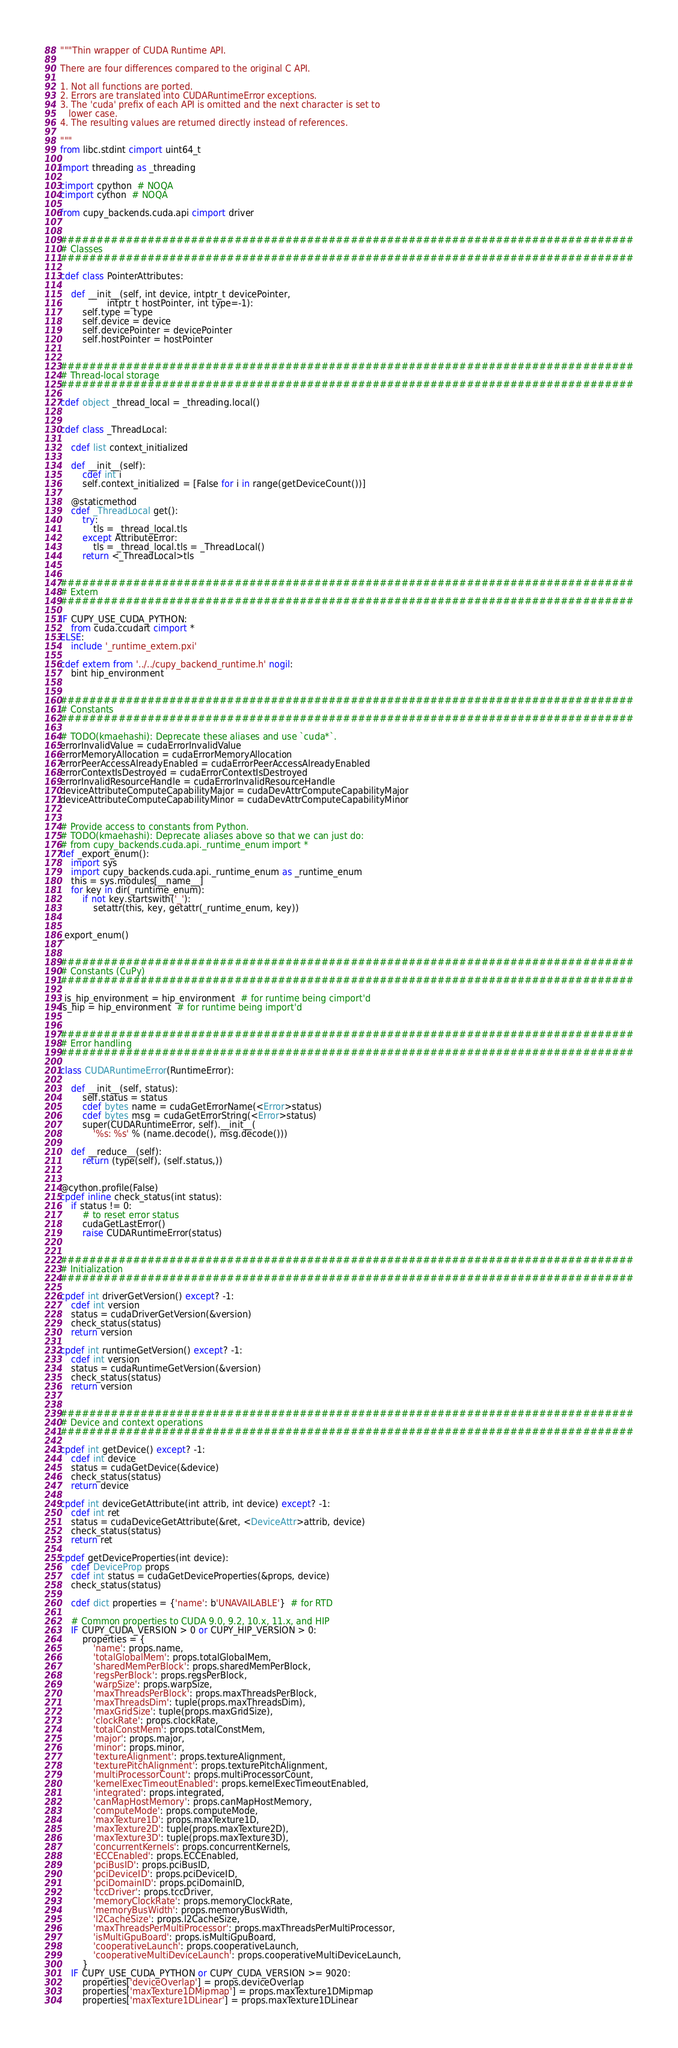Convert code to text. <code><loc_0><loc_0><loc_500><loc_500><_Cython_>"""Thin wrapper of CUDA Runtime API.

There are four differences compared to the original C API.

1. Not all functions are ported.
2. Errors are translated into CUDARuntimeError exceptions.
3. The 'cuda' prefix of each API is omitted and the next character is set to
   lower case.
4. The resulting values are returned directly instead of references.

"""
from libc.stdint cimport uint64_t

import threading as _threading

cimport cpython  # NOQA
cimport cython  # NOQA

from cupy_backends.cuda.api cimport driver


###############################################################################
# Classes
###############################################################################

cdef class PointerAttributes:

    def __init__(self, int device, intptr_t devicePointer,
                 intptr_t hostPointer, int type=-1):
        self.type = type
        self.device = device
        self.devicePointer = devicePointer
        self.hostPointer = hostPointer


###############################################################################
# Thread-local storage
###############################################################################

cdef object _thread_local = _threading.local()


cdef class _ThreadLocal:

    cdef list context_initialized

    def __init__(self):
        cdef int i
        self.context_initialized = [False for i in range(getDeviceCount())]

    @staticmethod
    cdef _ThreadLocal get():
        try:
            tls = _thread_local.tls
        except AttributeError:
            tls = _thread_local.tls = _ThreadLocal()
        return <_ThreadLocal>tls


###############################################################################
# Extern
###############################################################################

IF CUPY_USE_CUDA_PYTHON:
    from cuda.ccudart cimport *
ELSE:
    include '_runtime_extern.pxi'

cdef extern from '../../cupy_backend_runtime.h' nogil:
    bint hip_environment


###############################################################################
# Constants
###############################################################################

# TODO(kmaehashi): Deprecate these aliases and use `cuda*`.
errorInvalidValue = cudaErrorInvalidValue
errorMemoryAllocation = cudaErrorMemoryAllocation
errorPeerAccessAlreadyEnabled = cudaErrorPeerAccessAlreadyEnabled
errorContextIsDestroyed = cudaErrorContextIsDestroyed
errorInvalidResourceHandle = cudaErrorInvalidResourceHandle
deviceAttributeComputeCapabilityMajor = cudaDevAttrComputeCapabilityMajor
deviceAttributeComputeCapabilityMinor = cudaDevAttrComputeCapabilityMinor


# Provide access to constants from Python.
# TODO(kmaehashi): Deprecate aliases above so that we can just do:
# from cupy_backends.cuda.api._runtime_enum import *
def _export_enum():
    import sys
    import cupy_backends.cuda.api._runtime_enum as _runtime_enum
    this = sys.modules[__name__]
    for key in dir(_runtime_enum):
        if not key.startswith('_'):
            setattr(this, key, getattr(_runtime_enum, key))


_export_enum()


###############################################################################
# Constants (CuPy)
###############################################################################

_is_hip_environment = hip_environment  # for runtime being cimport'd
is_hip = hip_environment  # for runtime being import'd


###############################################################################
# Error handling
###############################################################################

class CUDARuntimeError(RuntimeError):

    def __init__(self, status):
        self.status = status
        cdef bytes name = cudaGetErrorName(<Error>status)
        cdef bytes msg = cudaGetErrorString(<Error>status)
        super(CUDARuntimeError, self).__init__(
            '%s: %s' % (name.decode(), msg.decode()))

    def __reduce__(self):
        return (type(self), (self.status,))


@cython.profile(False)
cpdef inline check_status(int status):
    if status != 0:
        # to reset error status
        cudaGetLastError()
        raise CUDARuntimeError(status)


###############################################################################
# Initialization
###############################################################################

cpdef int driverGetVersion() except? -1:
    cdef int version
    status = cudaDriverGetVersion(&version)
    check_status(status)
    return version

cpdef int runtimeGetVersion() except? -1:
    cdef int version
    status = cudaRuntimeGetVersion(&version)
    check_status(status)
    return version


###############################################################################
# Device and context operations
###############################################################################

cpdef int getDevice() except? -1:
    cdef int device
    status = cudaGetDevice(&device)
    check_status(status)
    return device

cpdef int deviceGetAttribute(int attrib, int device) except? -1:
    cdef int ret
    status = cudaDeviceGetAttribute(&ret, <DeviceAttr>attrib, device)
    check_status(status)
    return ret

cpdef getDeviceProperties(int device):
    cdef DeviceProp props
    cdef int status = cudaGetDeviceProperties(&props, device)
    check_status(status)

    cdef dict properties = {'name': b'UNAVAILABLE'}  # for RTD

    # Common properties to CUDA 9.0, 9.2, 10.x, 11.x, and HIP
    IF CUPY_CUDA_VERSION > 0 or CUPY_HIP_VERSION > 0:
        properties = {
            'name': props.name,
            'totalGlobalMem': props.totalGlobalMem,
            'sharedMemPerBlock': props.sharedMemPerBlock,
            'regsPerBlock': props.regsPerBlock,
            'warpSize': props.warpSize,
            'maxThreadsPerBlock': props.maxThreadsPerBlock,
            'maxThreadsDim': tuple(props.maxThreadsDim),
            'maxGridSize': tuple(props.maxGridSize),
            'clockRate': props.clockRate,
            'totalConstMem': props.totalConstMem,
            'major': props.major,
            'minor': props.minor,
            'textureAlignment': props.textureAlignment,
            'texturePitchAlignment': props.texturePitchAlignment,
            'multiProcessorCount': props.multiProcessorCount,
            'kernelExecTimeoutEnabled': props.kernelExecTimeoutEnabled,
            'integrated': props.integrated,
            'canMapHostMemory': props.canMapHostMemory,
            'computeMode': props.computeMode,
            'maxTexture1D': props.maxTexture1D,
            'maxTexture2D': tuple(props.maxTexture2D),
            'maxTexture3D': tuple(props.maxTexture3D),
            'concurrentKernels': props.concurrentKernels,
            'ECCEnabled': props.ECCEnabled,
            'pciBusID': props.pciBusID,
            'pciDeviceID': props.pciDeviceID,
            'pciDomainID': props.pciDomainID,
            'tccDriver': props.tccDriver,
            'memoryClockRate': props.memoryClockRate,
            'memoryBusWidth': props.memoryBusWidth,
            'l2CacheSize': props.l2CacheSize,
            'maxThreadsPerMultiProcessor': props.maxThreadsPerMultiProcessor,
            'isMultiGpuBoard': props.isMultiGpuBoard,
            'cooperativeLaunch': props.cooperativeLaunch,
            'cooperativeMultiDeviceLaunch': props.cooperativeMultiDeviceLaunch,
        }
    IF CUPY_USE_CUDA_PYTHON or CUPY_CUDA_VERSION >= 9020:
        properties['deviceOverlap'] = props.deviceOverlap
        properties['maxTexture1DMipmap'] = props.maxTexture1DMipmap
        properties['maxTexture1DLinear'] = props.maxTexture1DLinear</code> 